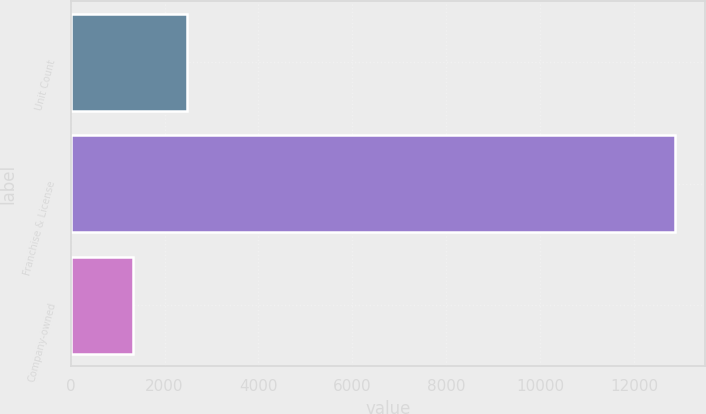<chart> <loc_0><loc_0><loc_500><loc_500><bar_chart><fcel>Unit Count<fcel>Franchise & License<fcel>Company-owned<nl><fcel>2478.1<fcel>12874<fcel>1323<nl></chart> 